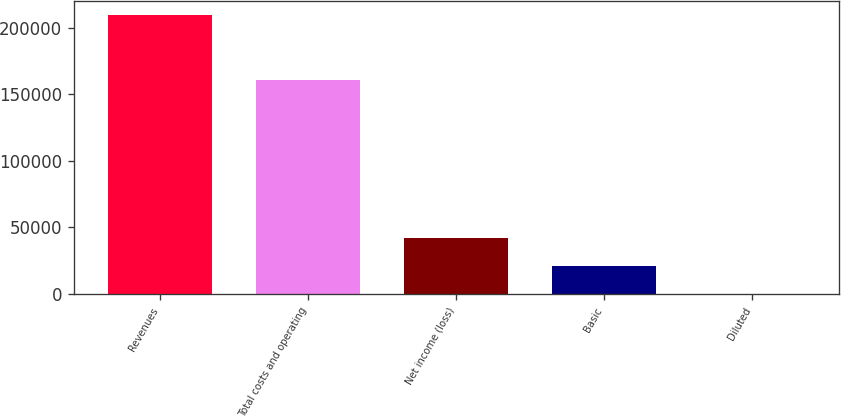Convert chart to OTSL. <chart><loc_0><loc_0><loc_500><loc_500><bar_chart><fcel>Revenues<fcel>Total costs and operating<fcel>Net income (loss)<fcel>Basic<fcel>Diluted<nl><fcel>210015<fcel>161048<fcel>42003.2<fcel>21001.7<fcel>0.25<nl></chart> 